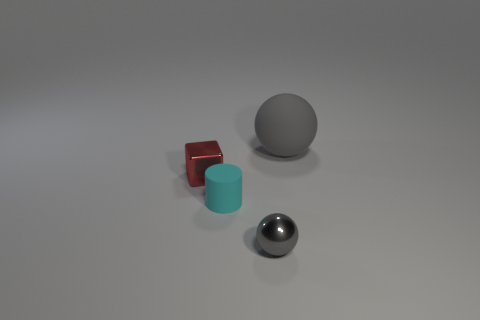How many other things are the same shape as the gray metal object?
Make the answer very short. 1. There is a rubber cylinder that is the same size as the metal block; what color is it?
Keep it short and to the point. Cyan. Are there an equal number of metal spheres to the left of the small gray sphere and metallic spheres?
Give a very brief answer. No. What shape is the object that is both on the right side of the tiny cylinder and in front of the large sphere?
Ensure brevity in your answer.  Sphere. Do the gray matte sphere and the gray metallic ball have the same size?
Offer a terse response. No. Are there any small green objects that have the same material as the big ball?
Keep it short and to the point. No. The rubber object that is the same color as the tiny metal sphere is what size?
Ensure brevity in your answer.  Large. What number of balls are in front of the cube and behind the red cube?
Keep it short and to the point. 0. There is a gray object that is in front of the red metal cube; what is its material?
Offer a very short reply. Metal. How many large rubber things are the same color as the shiny sphere?
Offer a terse response. 1. 